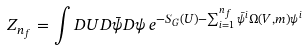<formula> <loc_0><loc_0><loc_500><loc_500>Z _ { n _ { f } } = \int D U D \bar { \psi } D \psi \, e ^ { - S _ { G } ( U ) - \sum ^ { n _ { f } } _ { i = 1 } \bar { \psi } ^ { i } \Omega ( V , m ) \psi ^ { i } }</formula> 